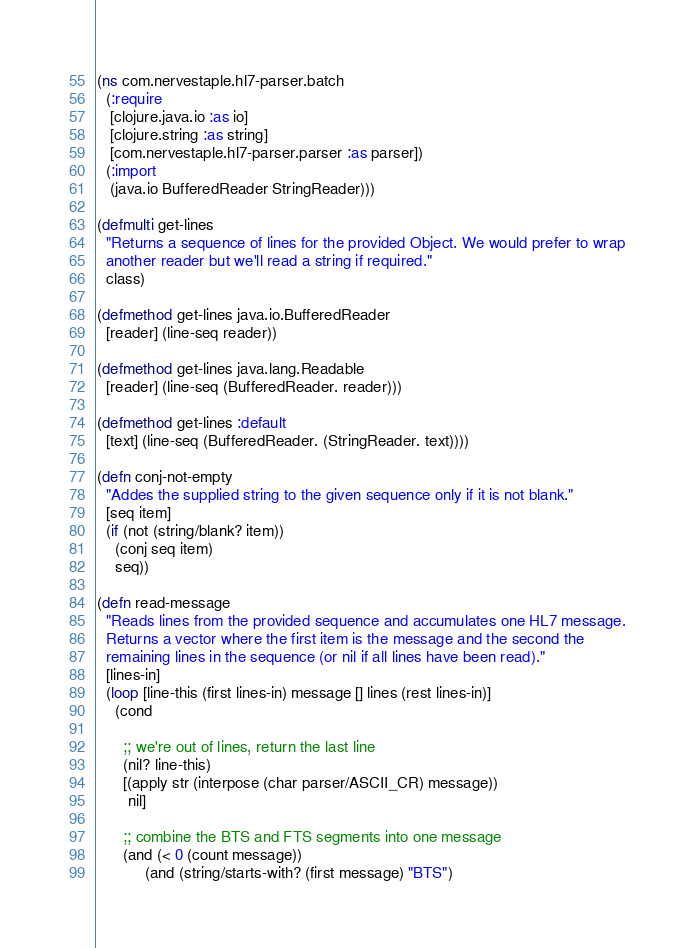<code> <loc_0><loc_0><loc_500><loc_500><_Clojure_>(ns com.nervestaple.hl7-parser.batch
  (:require
   [clojure.java.io :as io]
   [clojure.string :as string]
   [com.nervestaple.hl7-parser.parser :as parser])
  (:import
   (java.io BufferedReader StringReader)))

(defmulti get-lines
  "Returns a sequence of lines for the provided Object. We would prefer to wrap
  another reader but we'll read a string if required."
  class)

(defmethod get-lines java.io.BufferedReader
  [reader] (line-seq reader))

(defmethod get-lines java.lang.Readable
  [reader] (line-seq (BufferedReader. reader)))

(defmethod get-lines :default
  [text] (line-seq (BufferedReader. (StringReader. text))))

(defn conj-not-empty
  "Addes the supplied string to the given sequence only if it is not blank."
  [seq item]
  (if (not (string/blank? item))
    (conj seq item)
    seq))

(defn read-message
  "Reads lines from the provided sequence and accumulates one HL7 message.
  Returns a vector where the first item is the message and the second the
  remaining lines in the sequence (or nil if all lines have been read)."
  [lines-in]
  (loop [line-this (first lines-in) message [] lines (rest lines-in)]
    (cond

      ;; we're out of lines, return the last line
      (nil? line-this)
      [(apply str (interpose (char parser/ASCII_CR) message))
       nil]

      ;; combine the BTS and FTS segments into one message
      (and (< 0 (count message))
           (and (string/starts-with? (first message) "BTS")</code> 